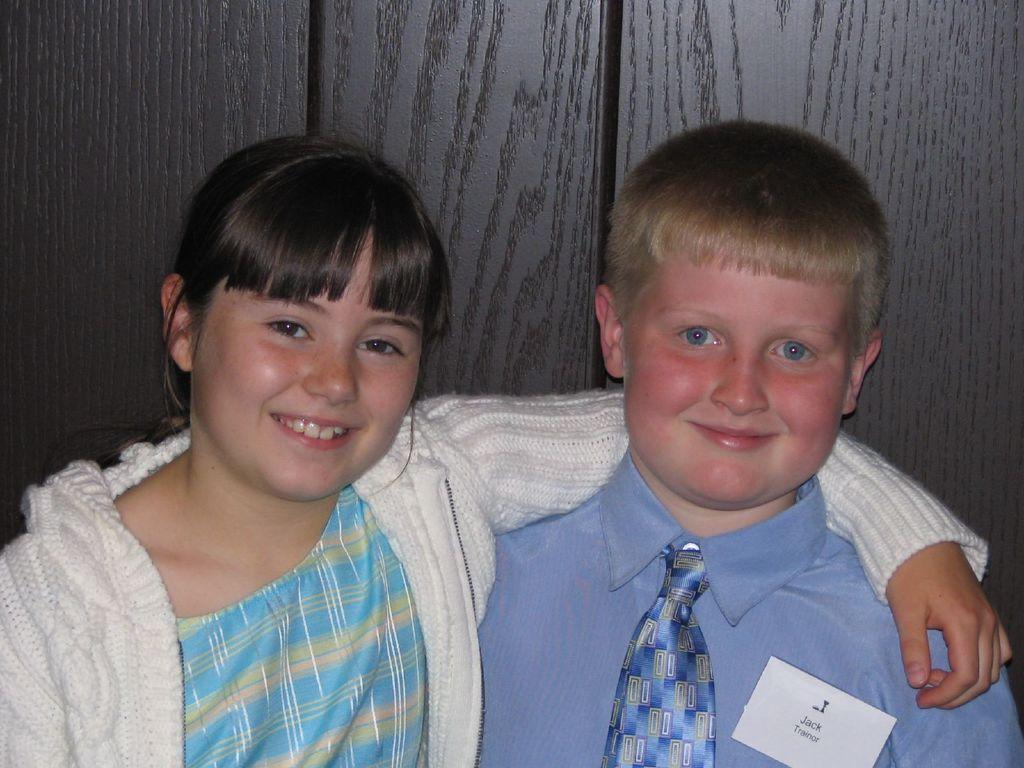Can you describe this image briefly? In this picture we can see a boy and a girl, they both are smiling and we can see a paper on his shirt. 